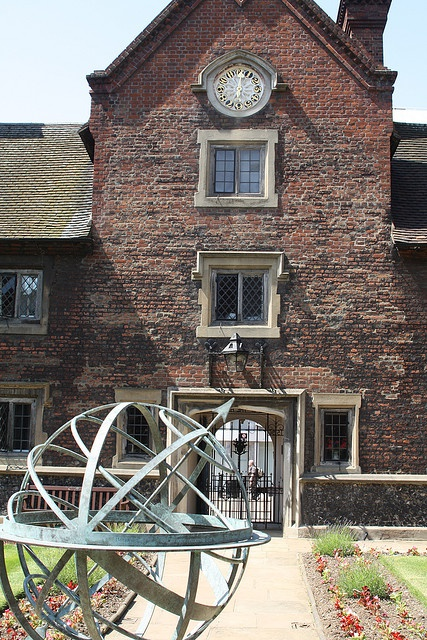Describe the objects in this image and their specific colors. I can see clock in white, darkgray, lightgray, gray, and beige tones and people in white, black, lightgray, gray, and darkgray tones in this image. 